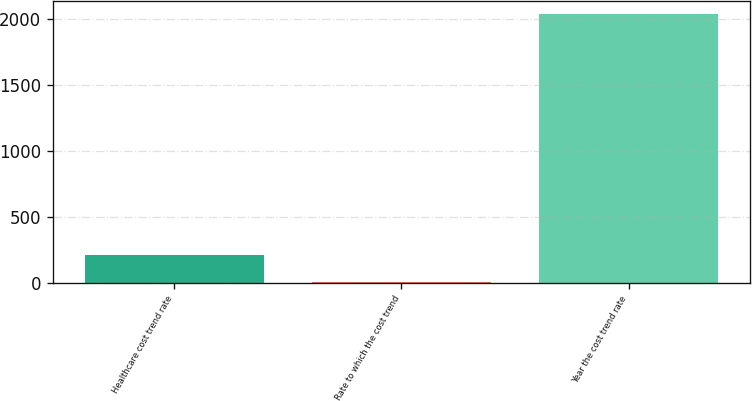Convert chart. <chart><loc_0><loc_0><loc_500><loc_500><bar_chart><fcel>Healthcare cost trend rate<fcel>Rate to which the cost trend<fcel>Year the cost trend rate<nl><fcel>207.76<fcel>4.4<fcel>2038<nl></chart> 